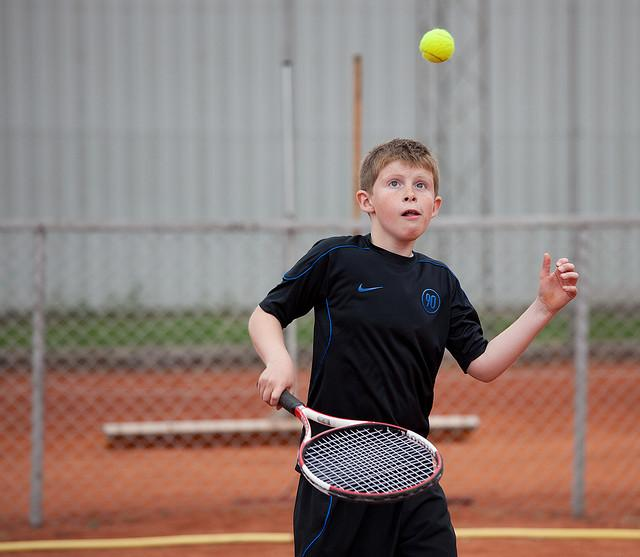What action will he take with the ball?

Choices:
A) roll
B) dunk
C) swing
D) dribble swing 